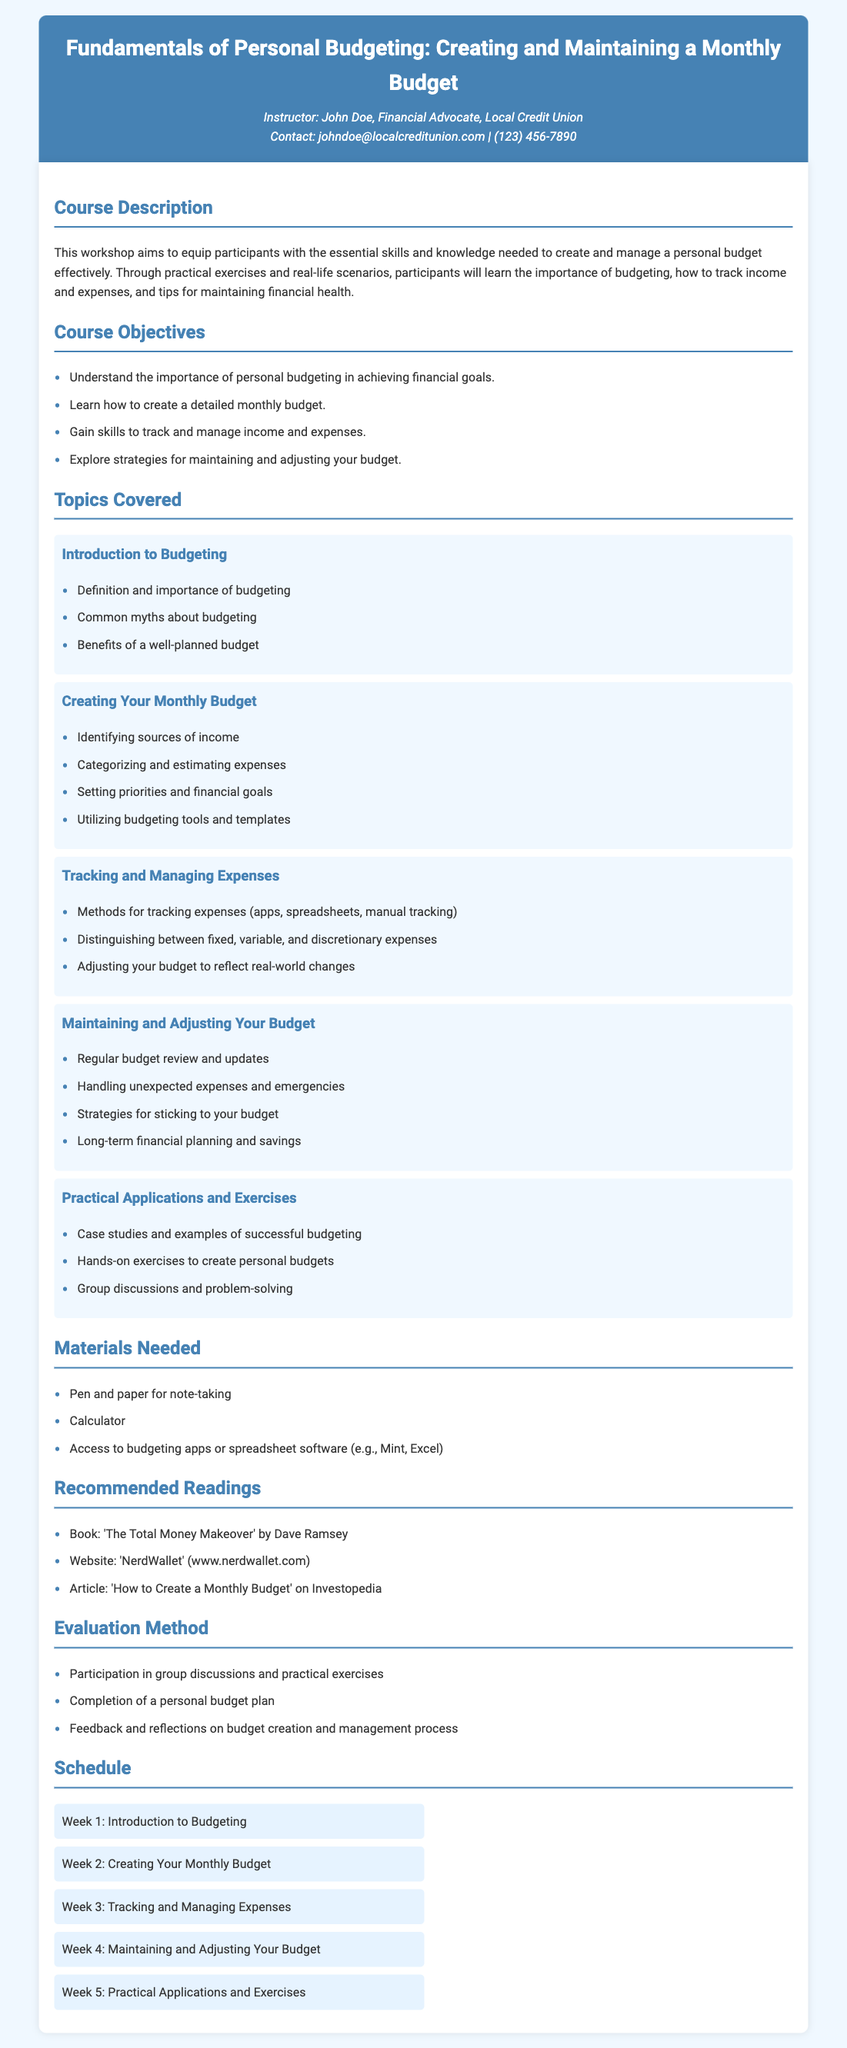What is the course title? The course title is prominently displayed at the top of the syllabus.
Answer: Fundamentals of Personal Budgeting: Creating and Maintaining a Monthly Budget Who is the instructor? The instructor's name is mentioned in the header section of the document.
Answer: John Doe What is one of the course objectives? The course objectives are listed under the Course Objectives section.
Answer: Understand the importance of personal budgeting in achieving financial goals How many weeks does the syllabus cover? The schedule section provides a clear breakdown of the weeks covered in the course.
Answer: 5 weeks What is one recommended reading? Recommended readings are provided in a specific section.
Answer: The Total Money Makeover by Dave Ramsey What type of method is used for evaluating participants? The Evaluation Method section outlines how participants will be assessed.
Answer: Participation in group discussions and practical exercises What materials are needed for the workshop? The Materials Needed section lists items that participants should bring.
Answer: Pen and paper for note-taking What topics are covered in the third week? The schedule provides an overview of weekly topics covered in the course.
Answer: Tracking and Managing Expenses What is one strategy for maintaining your budget? The topics covered section includes strategies for budget maintenance.
Answer: Strategies for sticking to your budget 